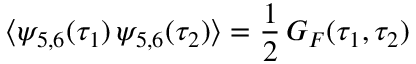<formula> <loc_0><loc_0><loc_500><loc_500>\langle \psi _ { 5 , 6 } ( \tau _ { 1 } ) \, \psi _ { 5 , 6 } ( \tau _ { 2 } ) \rangle = \frac { 1 } { 2 } \, G _ { F } ( \tau _ { 1 } , \tau _ { 2 } )</formula> 